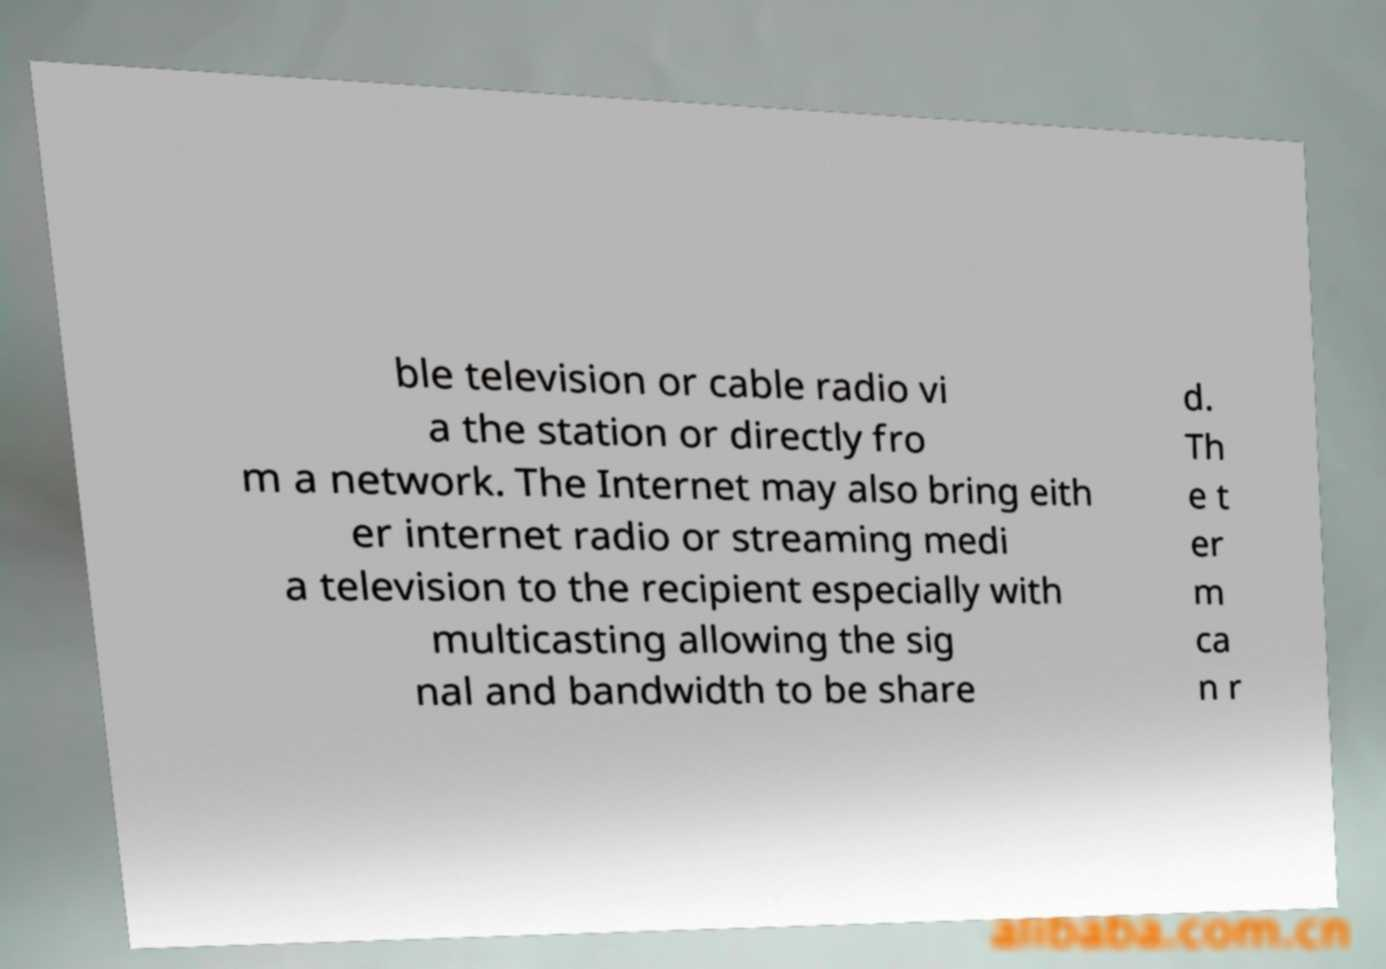For documentation purposes, I need the text within this image transcribed. Could you provide that? ble television or cable radio vi a the station or directly fro m a network. The Internet may also bring eith er internet radio or streaming medi a television to the recipient especially with multicasting allowing the sig nal and bandwidth to be share d. Th e t er m ca n r 